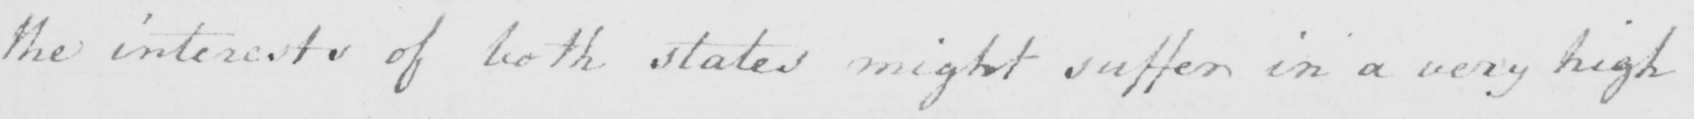What text is written in this handwritten line? the interests of both states might suffer in a very high 